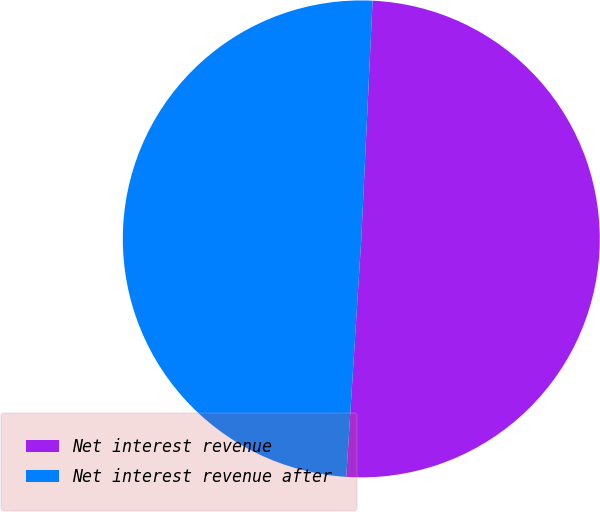Convert chart. <chart><loc_0><loc_0><loc_500><loc_500><pie_chart><fcel>Net interest revenue<fcel>Net interest revenue after<nl><fcel>50.25%<fcel>49.75%<nl></chart> 